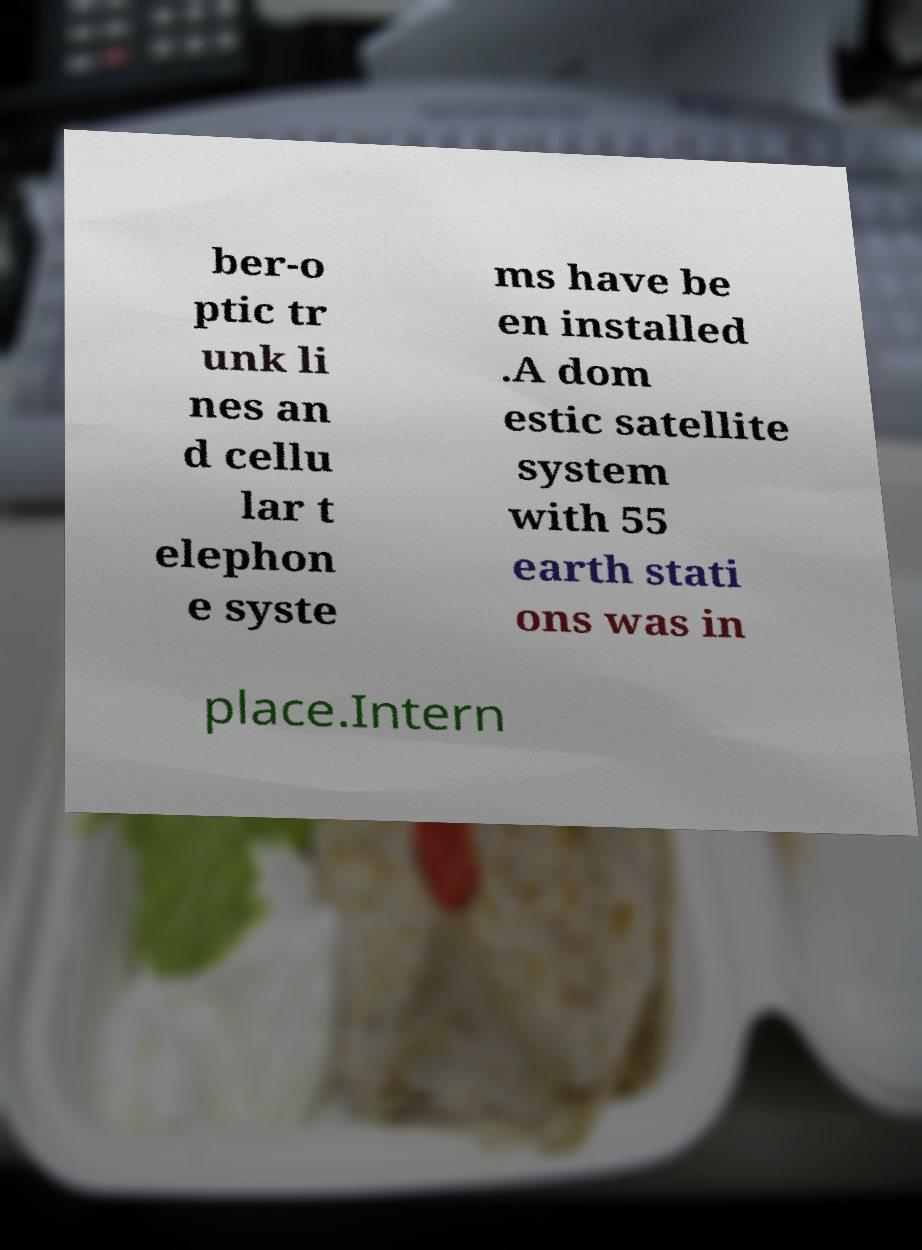There's text embedded in this image that I need extracted. Can you transcribe it verbatim? ber-o ptic tr unk li nes an d cellu lar t elephon e syste ms have be en installed .A dom estic satellite system with 55 earth stati ons was in place.Intern 